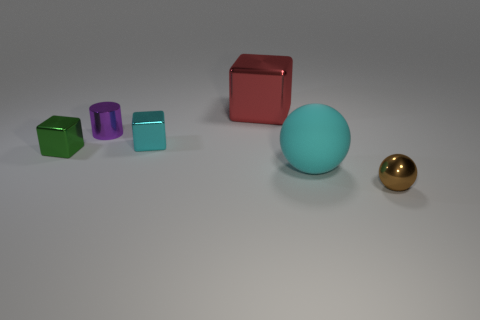There is a small cyan block; what number of small metal things are to the right of it?
Ensure brevity in your answer.  1. Are the big red object and the object that is to the left of the purple metal cylinder made of the same material?
Provide a succinct answer. Yes. Are there any blue cubes that have the same size as the brown ball?
Offer a terse response. No. Are there the same number of purple metal cylinders that are in front of the cyan matte object and metallic things?
Give a very brief answer. No. The green thing is what size?
Give a very brief answer. Small. There is a small thing to the left of the purple metallic object; how many blocks are to the right of it?
Your answer should be compact. 2. What is the shape of the object that is both to the right of the red shiny thing and to the left of the tiny brown shiny ball?
Your answer should be very brief. Sphere. What number of tiny cubes have the same color as the large block?
Make the answer very short. 0. Is there a small thing right of the cyan thing in front of the tiny metallic thing left of the purple metallic object?
Give a very brief answer. Yes. There is a metallic thing that is both on the right side of the cyan metallic block and left of the large cyan rubber sphere; how big is it?
Ensure brevity in your answer.  Large. 